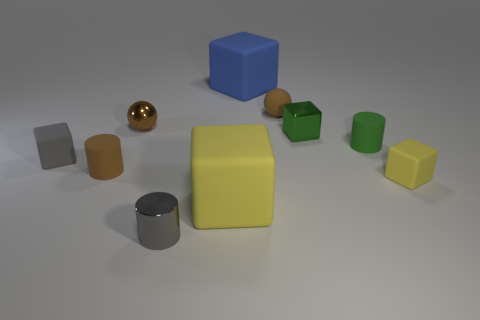What number of metallic objects are gray objects or small cylinders?
Ensure brevity in your answer.  1. How many small metal objects are there?
Ensure brevity in your answer.  3. The metal ball that is the same size as the brown matte sphere is what color?
Keep it short and to the point. Brown. Is the gray rubber cube the same size as the blue matte cube?
Give a very brief answer. No. There is a tiny object that is the same color as the small shiny cylinder; what is its shape?
Make the answer very short. Cube. There is a blue thing; does it have the same size as the yellow matte thing to the right of the big blue matte cube?
Offer a terse response. No. There is a cube that is both to the right of the gray metallic thing and on the left side of the big blue matte cube; what color is it?
Offer a terse response. Yellow. Are there more brown cylinders that are in front of the gray shiny object than tiny green metal objects behind the big yellow rubber object?
Offer a very short reply. No. There is a ball that is the same material as the green cube; what size is it?
Offer a very short reply. Small. How many gray objects are on the left side of the small cylinder that is in front of the small yellow cube?
Give a very brief answer. 1. 